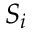<formula> <loc_0><loc_0><loc_500><loc_500>S _ { i }</formula> 